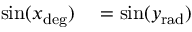<formula> <loc_0><loc_0><loc_500><loc_500>\begin{array} { r l } { \sin ( x _ { d e g } ) } & = \sin ( y _ { r a d } ) } \end{array}</formula> 